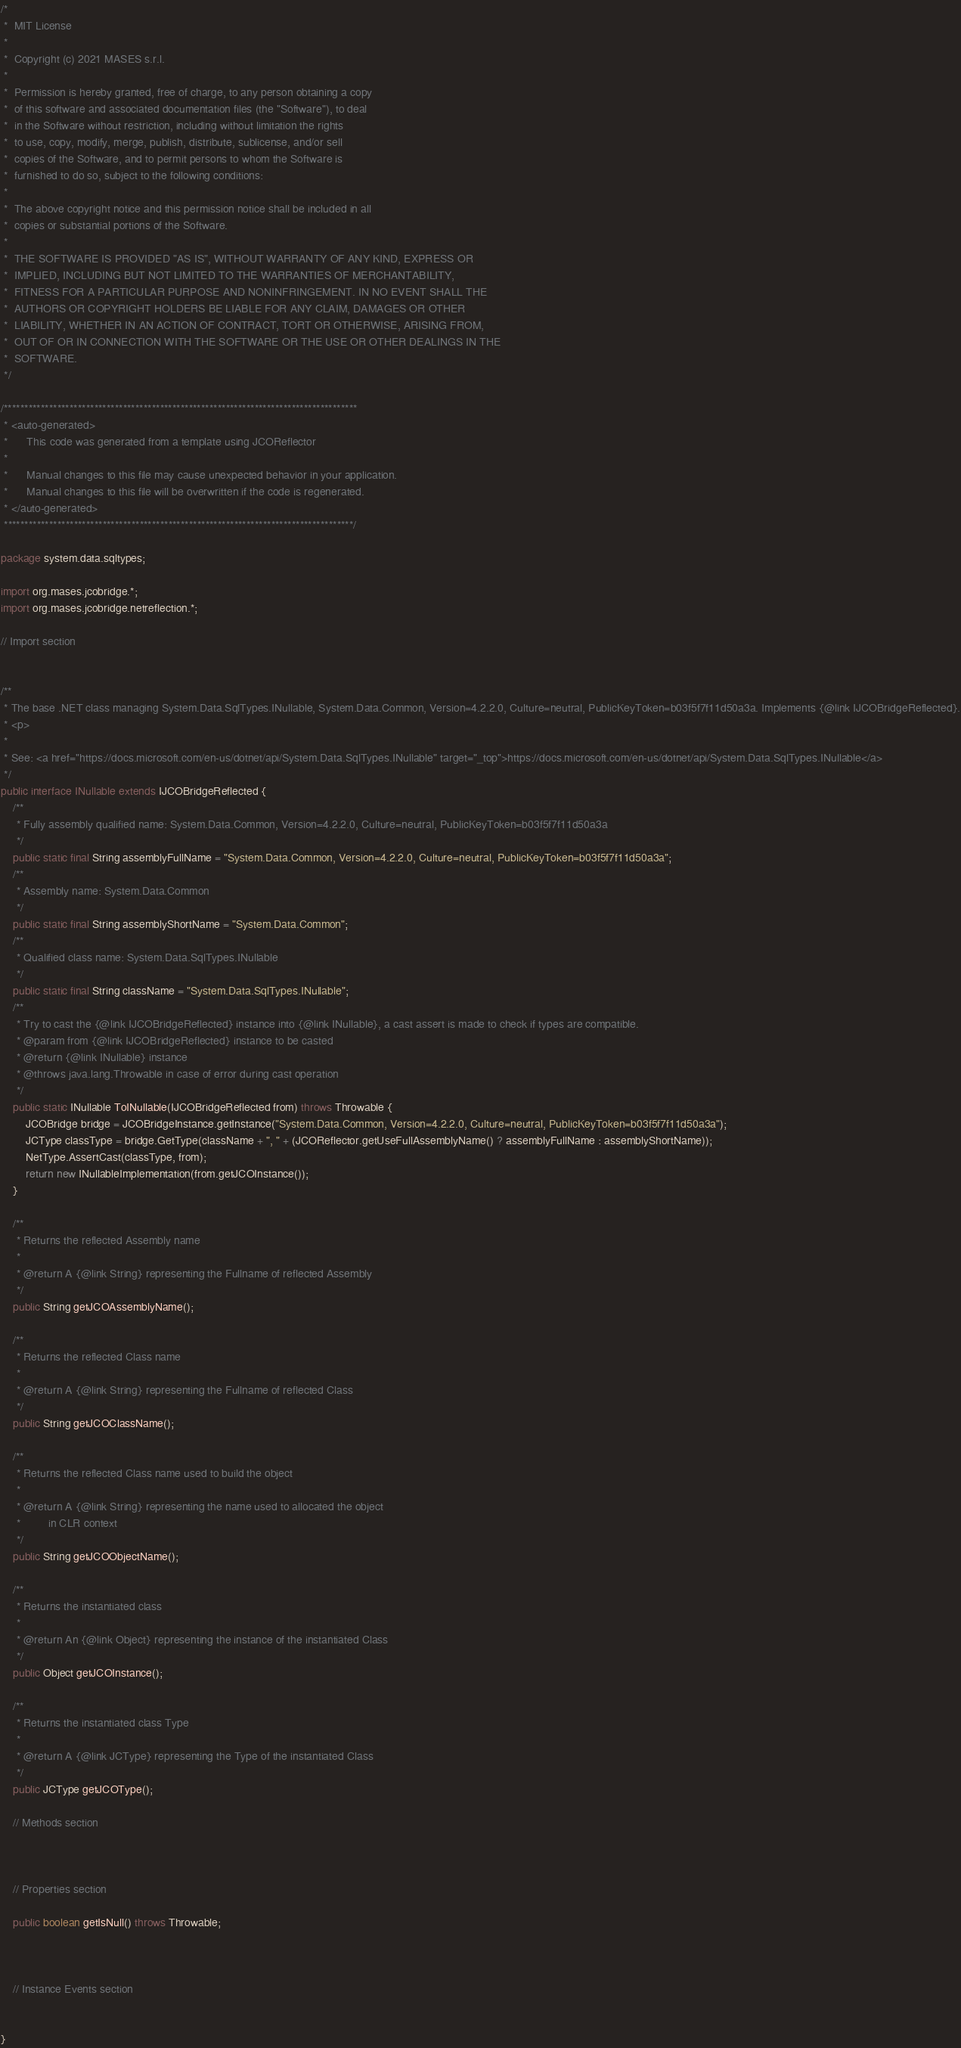<code> <loc_0><loc_0><loc_500><loc_500><_Java_>/*
 *  MIT License
 *
 *  Copyright (c) 2021 MASES s.r.l.
 *
 *  Permission is hereby granted, free of charge, to any person obtaining a copy
 *  of this software and associated documentation files (the "Software"), to deal
 *  in the Software without restriction, including without limitation the rights
 *  to use, copy, modify, merge, publish, distribute, sublicense, and/or sell
 *  copies of the Software, and to permit persons to whom the Software is
 *  furnished to do so, subject to the following conditions:
 *
 *  The above copyright notice and this permission notice shall be included in all
 *  copies or substantial portions of the Software.
 *
 *  THE SOFTWARE IS PROVIDED "AS IS", WITHOUT WARRANTY OF ANY KIND, EXPRESS OR
 *  IMPLIED, INCLUDING BUT NOT LIMITED TO THE WARRANTIES OF MERCHANTABILITY,
 *  FITNESS FOR A PARTICULAR PURPOSE AND NONINFRINGEMENT. IN NO EVENT SHALL THE
 *  AUTHORS OR COPYRIGHT HOLDERS BE LIABLE FOR ANY CLAIM, DAMAGES OR OTHER
 *  LIABILITY, WHETHER IN AN ACTION OF CONTRACT, TORT OR OTHERWISE, ARISING FROM,
 *  OUT OF OR IN CONNECTION WITH THE SOFTWARE OR THE USE OR OTHER DEALINGS IN THE
 *  SOFTWARE.
 */

/**************************************************************************************
 * <auto-generated>
 *      This code was generated from a template using JCOReflector
 * 
 *      Manual changes to this file may cause unexpected behavior in your application.
 *      Manual changes to this file will be overwritten if the code is regenerated.
 * </auto-generated>
 *************************************************************************************/

package system.data.sqltypes;

import org.mases.jcobridge.*;
import org.mases.jcobridge.netreflection.*;

// Import section


/**
 * The base .NET class managing System.Data.SqlTypes.INullable, System.Data.Common, Version=4.2.2.0, Culture=neutral, PublicKeyToken=b03f5f7f11d50a3a. Implements {@link IJCOBridgeReflected}.
 * <p>
 * 
 * See: <a href="https://docs.microsoft.com/en-us/dotnet/api/System.Data.SqlTypes.INullable" target="_top">https://docs.microsoft.com/en-us/dotnet/api/System.Data.SqlTypes.INullable</a>
 */
public interface INullable extends IJCOBridgeReflected {
    /**
     * Fully assembly qualified name: System.Data.Common, Version=4.2.2.0, Culture=neutral, PublicKeyToken=b03f5f7f11d50a3a
     */
    public static final String assemblyFullName = "System.Data.Common, Version=4.2.2.0, Culture=neutral, PublicKeyToken=b03f5f7f11d50a3a";
    /**
     * Assembly name: System.Data.Common
     */
    public static final String assemblyShortName = "System.Data.Common";
    /**
     * Qualified class name: System.Data.SqlTypes.INullable
     */
    public static final String className = "System.Data.SqlTypes.INullable";
    /**
     * Try to cast the {@link IJCOBridgeReflected} instance into {@link INullable}, a cast assert is made to check if types are compatible.
     * @param from {@link IJCOBridgeReflected} instance to be casted
     * @return {@link INullable} instance
     * @throws java.lang.Throwable in case of error during cast operation
     */
    public static INullable ToINullable(IJCOBridgeReflected from) throws Throwable {
        JCOBridge bridge = JCOBridgeInstance.getInstance("System.Data.Common, Version=4.2.2.0, Culture=neutral, PublicKeyToken=b03f5f7f11d50a3a");
        JCType classType = bridge.GetType(className + ", " + (JCOReflector.getUseFullAssemblyName() ? assemblyFullName : assemblyShortName));
        NetType.AssertCast(classType, from);
        return new INullableImplementation(from.getJCOInstance());
    }

    /**
     * Returns the reflected Assembly name
     * 
     * @return A {@link String} representing the Fullname of reflected Assembly
     */
    public String getJCOAssemblyName();

    /**
     * Returns the reflected Class name
     * 
     * @return A {@link String} representing the Fullname of reflected Class
     */
    public String getJCOClassName();

    /**
     * Returns the reflected Class name used to build the object
     * 
     * @return A {@link String} representing the name used to allocated the object
     *         in CLR context
     */
    public String getJCOObjectName();

    /**
     * Returns the instantiated class
     * 
     * @return An {@link Object} representing the instance of the instantiated Class
     */
    public Object getJCOInstance();

    /**
     * Returns the instantiated class Type
     * 
     * @return A {@link JCType} representing the Type of the instantiated Class
     */
    public JCType getJCOType();

    // Methods section
    

    
    // Properties section
    
    public boolean getIsNull() throws Throwable;



    // Instance Events section
    

}</code> 